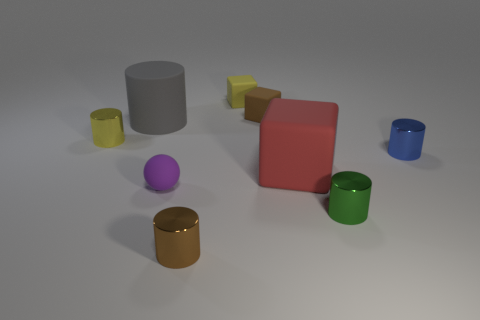How many tiny purple rubber spheres are there?
Offer a terse response. 1. What number of things have the same size as the brown cylinder?
Provide a succinct answer. 6. What is the material of the ball?
Give a very brief answer. Rubber. There is a big matte cylinder; does it have the same color as the tiny shiny object on the left side of the brown metallic cylinder?
Provide a succinct answer. No. There is a rubber object that is to the left of the tiny yellow block and behind the large red block; how big is it?
Your answer should be very brief. Large. What is the shape of the large red thing that is the same material as the small brown cube?
Offer a terse response. Cube. Does the ball have the same material as the yellow block that is right of the big cylinder?
Provide a short and direct response. Yes. There is a tiny yellow object that is to the left of the brown shiny cylinder; is there a small yellow block that is in front of it?
Keep it short and to the point. No. There is a large object that is the same shape as the tiny yellow metal object; what is its material?
Your answer should be very brief. Rubber. There is a metal cylinder that is on the right side of the green cylinder; how many rubber balls are on the left side of it?
Offer a terse response. 1. 